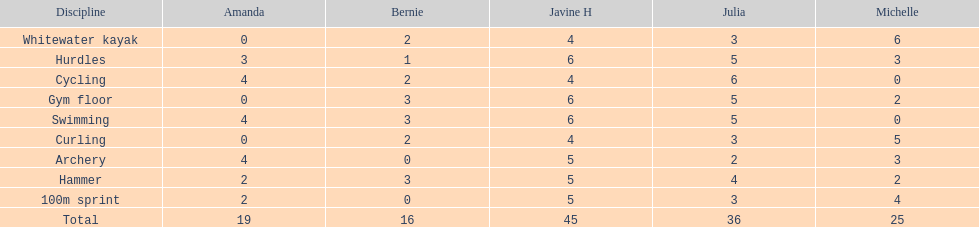In addition to amanda, who is the other girl with a 4 in cycling? Javine H. 